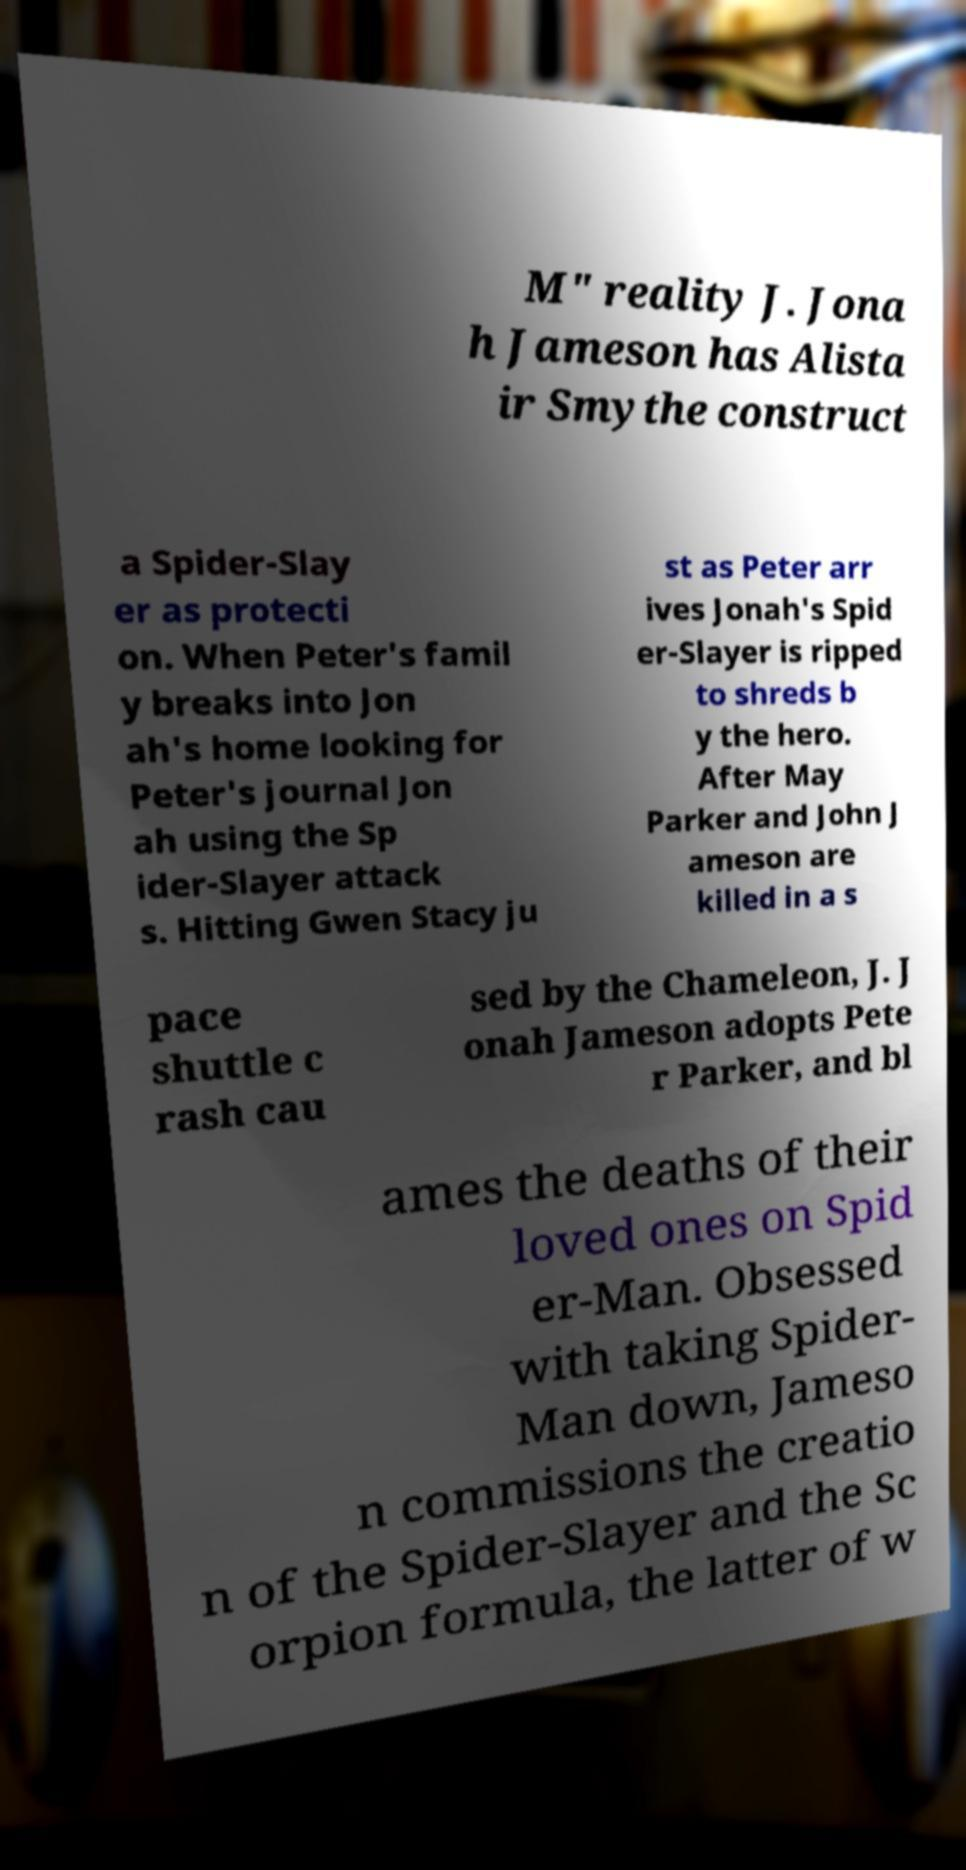For documentation purposes, I need the text within this image transcribed. Could you provide that? M" reality J. Jona h Jameson has Alista ir Smythe construct a Spider-Slay er as protecti on. When Peter's famil y breaks into Jon ah's home looking for Peter's journal Jon ah using the Sp ider-Slayer attack s. Hitting Gwen Stacy ju st as Peter arr ives Jonah's Spid er-Slayer is ripped to shreds b y the hero. After May Parker and John J ameson are killed in a s pace shuttle c rash cau sed by the Chameleon, J. J onah Jameson adopts Pete r Parker, and bl ames the deaths of their loved ones on Spid er-Man. Obsessed with taking Spider- Man down, Jameso n commissions the creatio n of the Spider-Slayer and the Sc orpion formula, the latter of w 